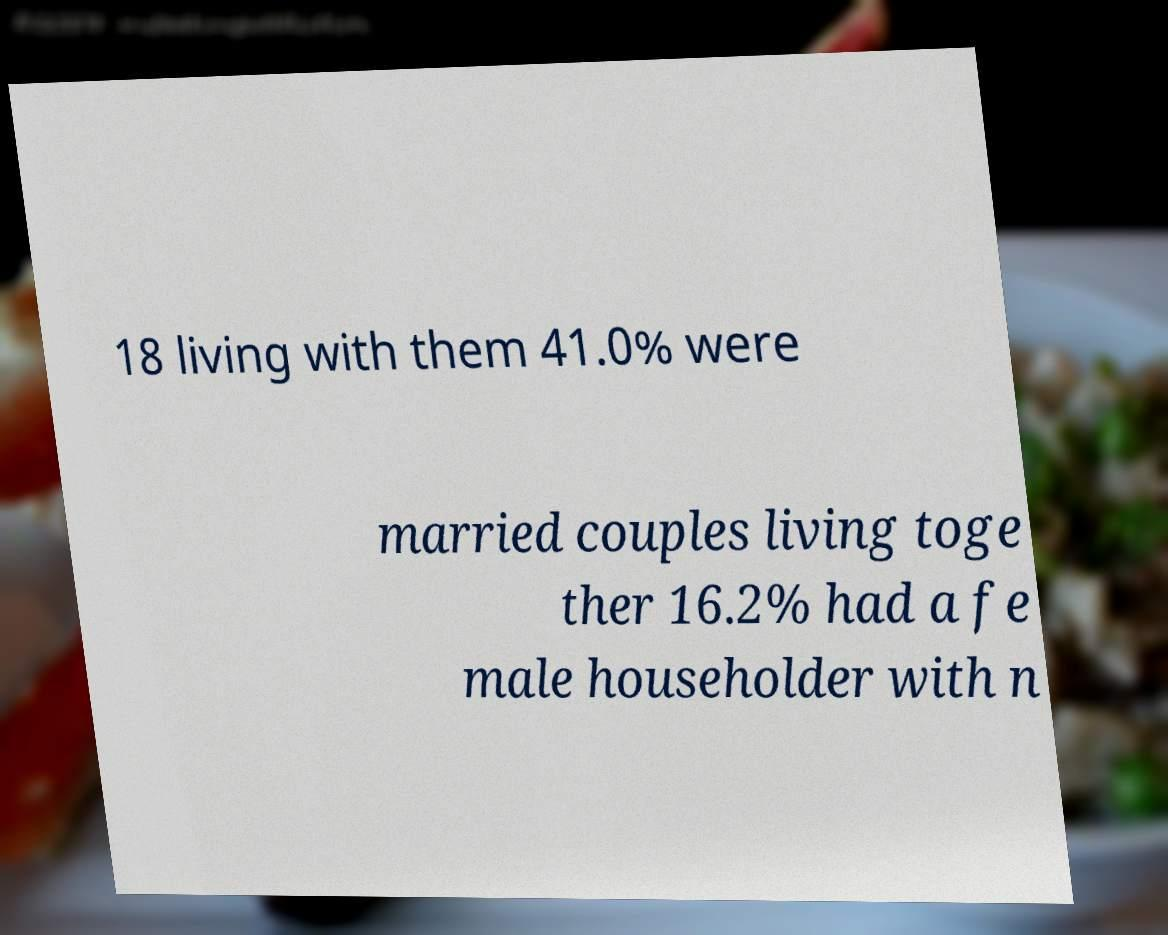I need the written content from this picture converted into text. Can you do that? 18 living with them 41.0% were married couples living toge ther 16.2% had a fe male householder with n 